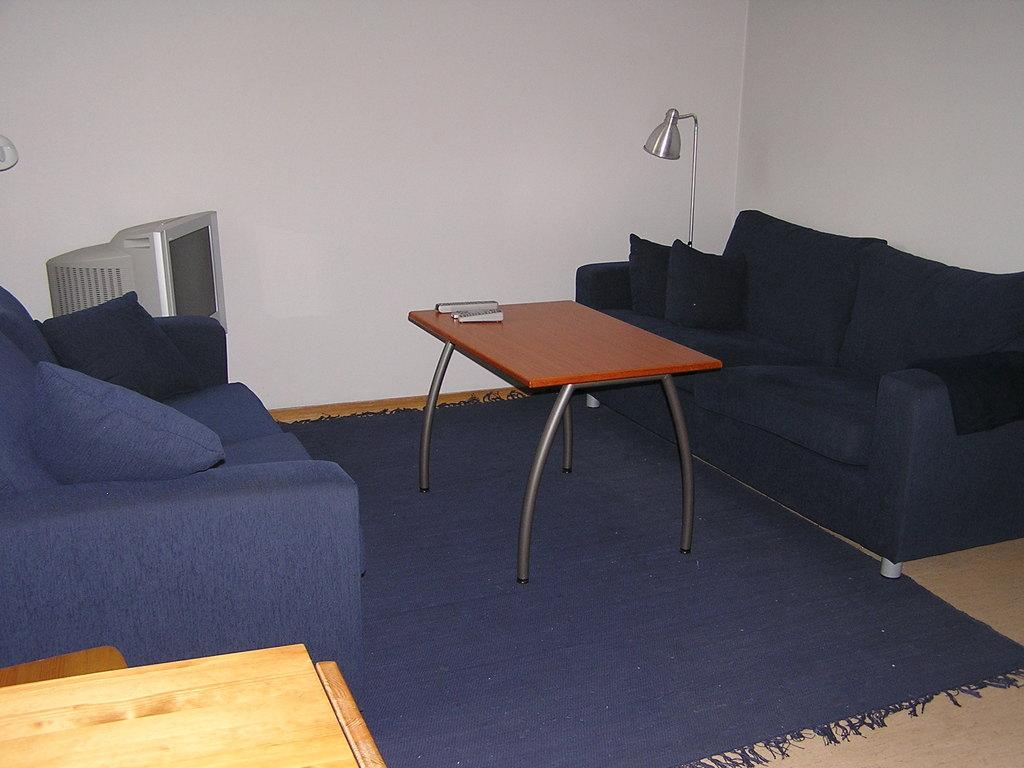What type of furniture is present in the image? There are couches with pillows in the image. What object can be seen on the table in the image? There is a remote on the table in the image. What electronic device is visible in the image? There is a television in the image. What type of lighting is present in the image? There is a lamp in the image. What type of floor covering is present in the image? The floor has a carpet in the image. What type of seed is growing on the television in the image? There is no seed growing on the television in the image; it is an electronic device. 